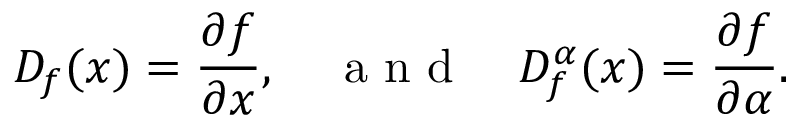Convert formula to latex. <formula><loc_0><loc_0><loc_500><loc_500>D _ { f } ( x ) = \frac { \partial f } { \partial x } , \quad a n d \quad D _ { f } ^ { \alpha } ( x ) = \frac { \partial f } { \partial \alpha } .</formula> 